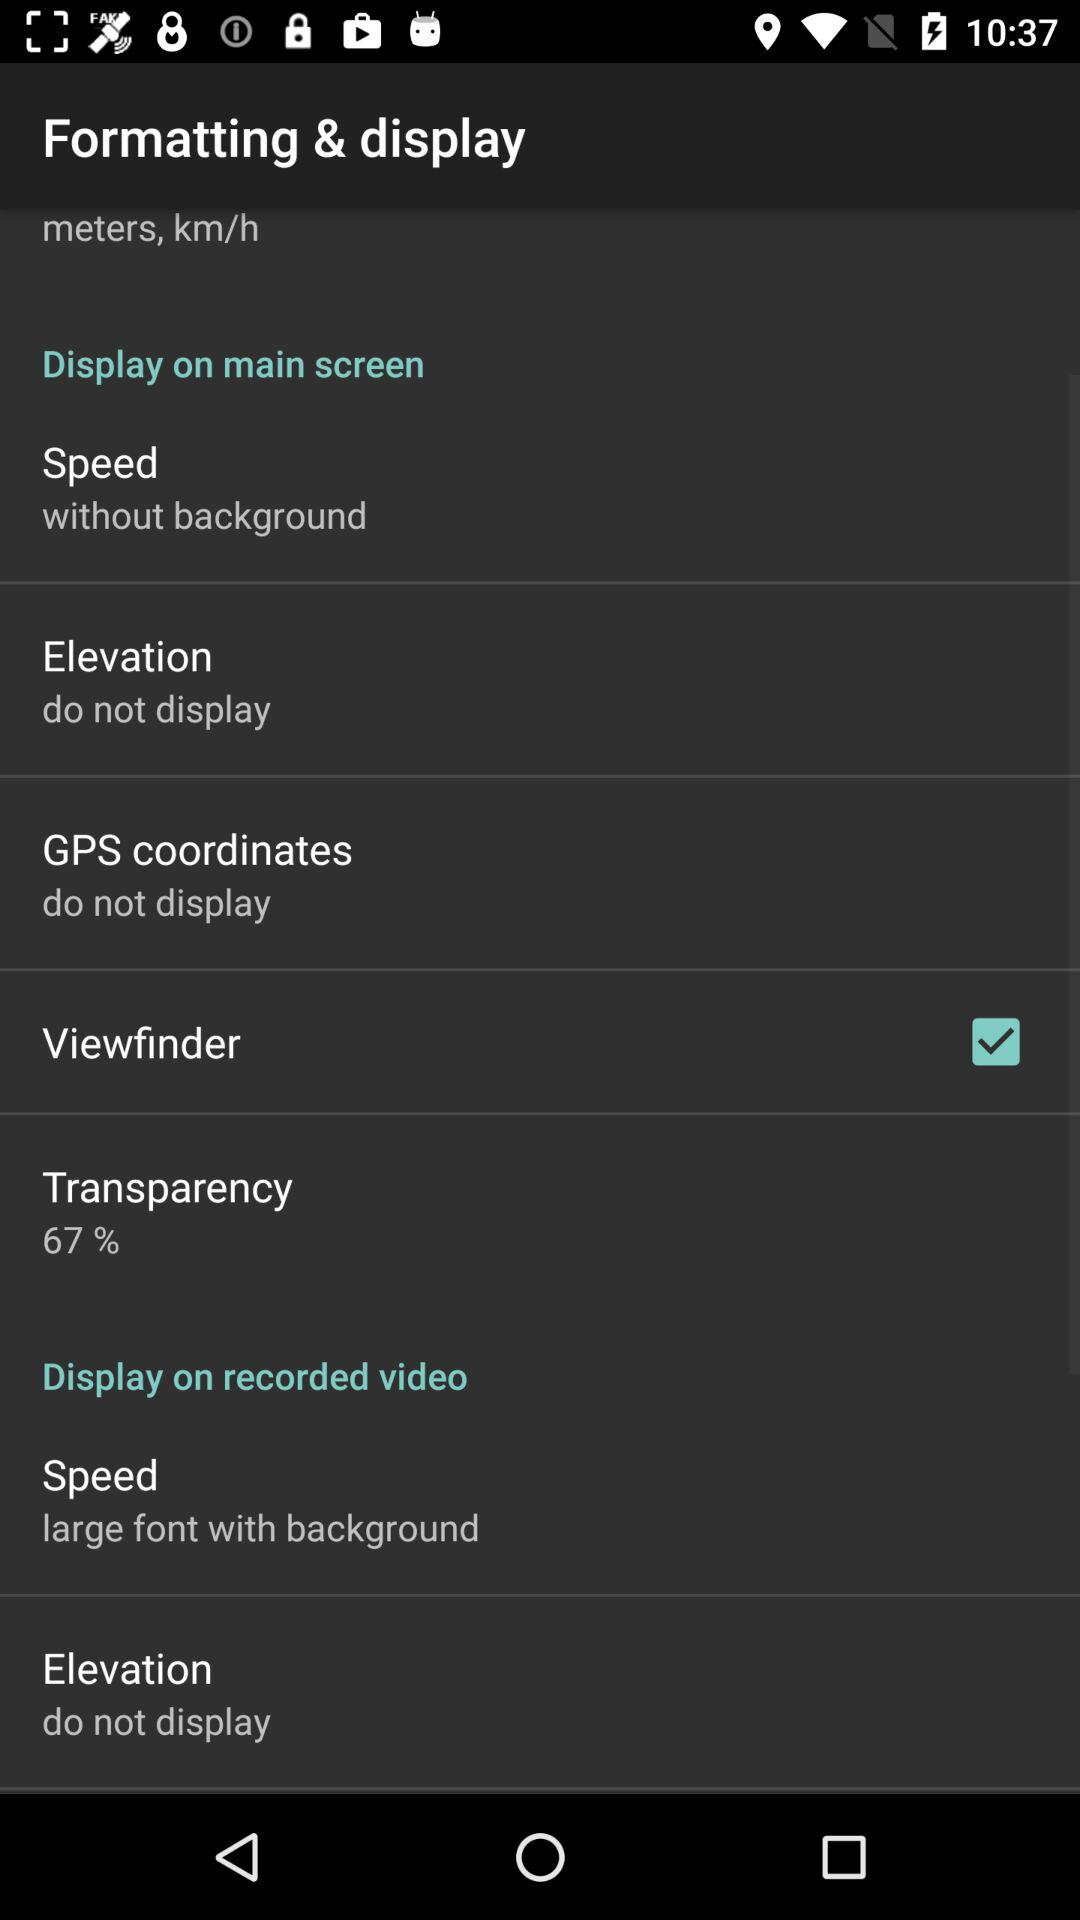What is the status of "Viewfinder"? The status is "on". 